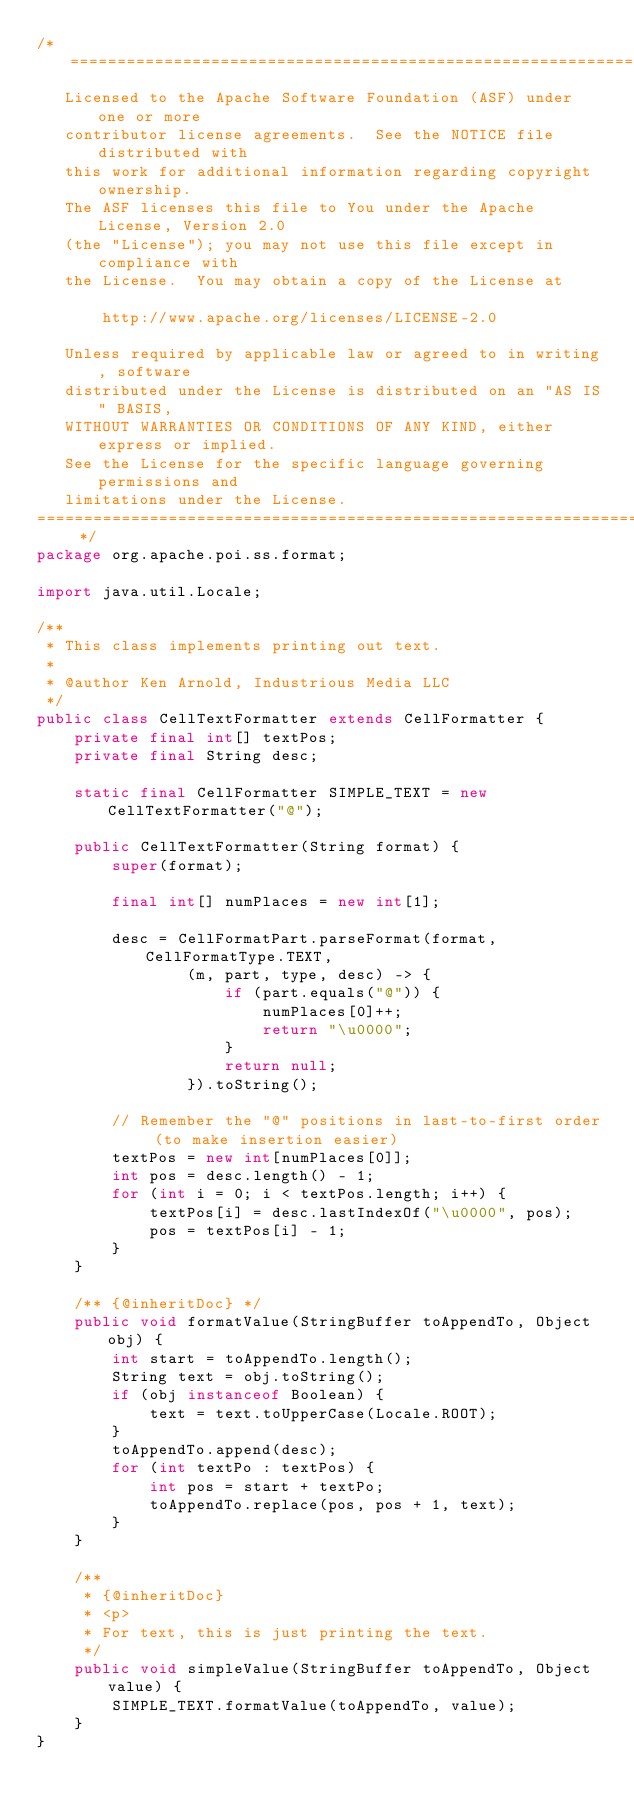Convert code to text. <code><loc_0><loc_0><loc_500><loc_500><_Java_>/* ====================================================================
   Licensed to the Apache Software Foundation (ASF) under one or more
   contributor license agreements.  See the NOTICE file distributed with
   this work for additional information regarding copyright ownership.
   The ASF licenses this file to You under the Apache License, Version 2.0
   (the "License"); you may not use this file except in compliance with
   the License.  You may obtain a copy of the License at

       http://www.apache.org/licenses/LICENSE-2.0

   Unless required by applicable law or agreed to in writing, software
   distributed under the License is distributed on an "AS IS" BASIS,
   WITHOUT WARRANTIES OR CONDITIONS OF ANY KIND, either express or implied.
   See the License for the specific language governing permissions and
   limitations under the License.
==================================================================== */
package org.apache.poi.ss.format;

import java.util.Locale;

/**
 * This class implements printing out text.
 *
 * @author Ken Arnold, Industrious Media LLC
 */
public class CellTextFormatter extends CellFormatter {
    private final int[] textPos;
    private final String desc;

    static final CellFormatter SIMPLE_TEXT = new CellTextFormatter("@");

    public CellTextFormatter(String format) {
        super(format);

        final int[] numPlaces = new int[1];

        desc = CellFormatPart.parseFormat(format, CellFormatType.TEXT,
                (m, part, type, desc) -> {
                    if (part.equals("@")) {
                        numPlaces[0]++;
                        return "\u0000";
                    }
                    return null;
                }).toString();

        // Remember the "@" positions in last-to-first order (to make insertion easier)
        textPos = new int[numPlaces[0]];
        int pos = desc.length() - 1;
        for (int i = 0; i < textPos.length; i++) {
            textPos[i] = desc.lastIndexOf("\u0000", pos);
            pos = textPos[i] - 1;
        }
    }

    /** {@inheritDoc} */
    public void formatValue(StringBuffer toAppendTo, Object obj) {
        int start = toAppendTo.length();
        String text = obj.toString();
        if (obj instanceof Boolean) {
            text = text.toUpperCase(Locale.ROOT);
        }
        toAppendTo.append(desc);
        for (int textPo : textPos) {
            int pos = start + textPo;
            toAppendTo.replace(pos, pos + 1, text);
        }
    }

    /**
     * {@inheritDoc}
     * <p>
     * For text, this is just printing the text.
     */
    public void simpleValue(StringBuffer toAppendTo, Object value) {
        SIMPLE_TEXT.formatValue(toAppendTo, value);
    }
}
</code> 